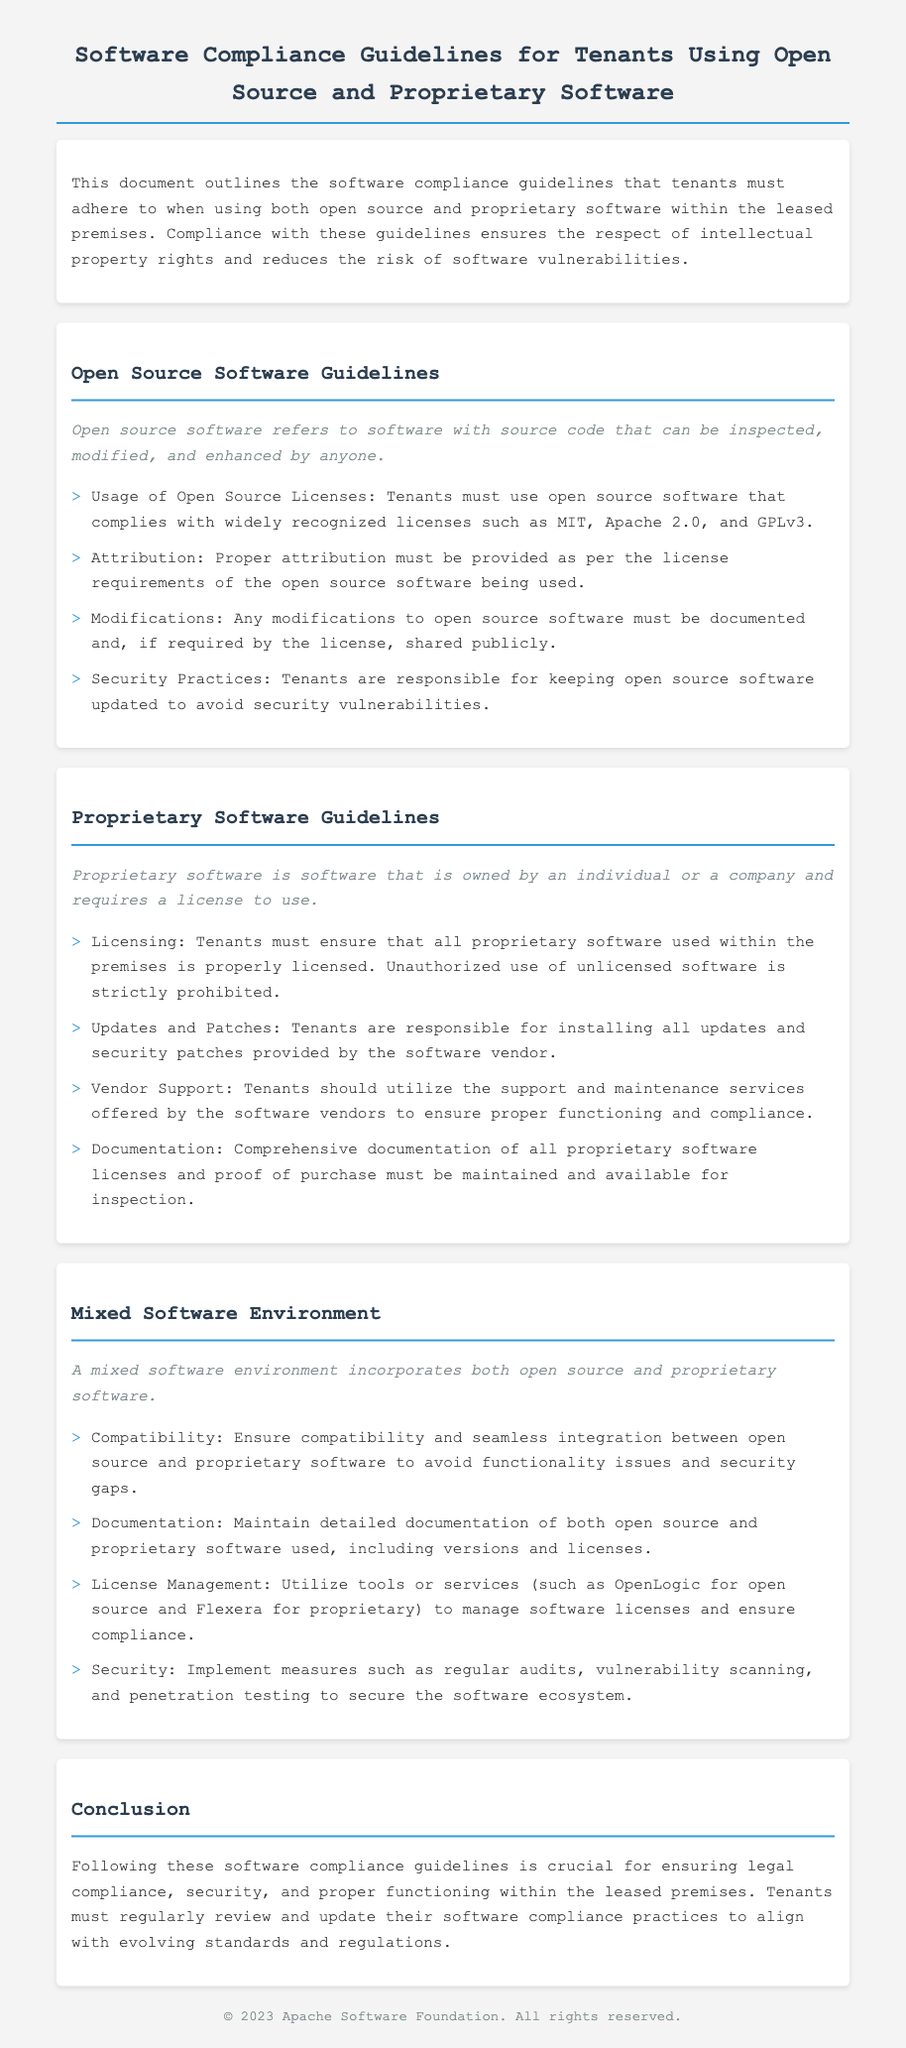What is the title of the document? The title of the document is stated in the header of the rendered page.
Answer: Software Compliance Guidelines for Tenants Using Open Source and Proprietary Software What are the types of software mentioned in the guidelines? The document outlines compliance guidelines for two types of software, which are indicated in the sections.
Answer: Open Source and Proprietary Software What must tenants ensure about proprietary software? This requirement is listed under the Proprietary Software Guidelines section.
Answer: Properly licensed Which licenses must open source software comply with? The document specifies recognized licenses in the Open Source Software Guidelines section.
Answer: MIT, Apache 2.0, and GPLv3 What should be maintained for all proprietary software? This requirement is found in the Proprietary Software Guidelines section, specifically about documentation.
Answer: Comprehensive documentation What is recommended for ensuring compatibility in a mixed software environment? This is mentioned in the Mixed Software Environment guidelines regarding software integration.
Answer: Ensure compatibility and seamless integration What kind of practices must tenants follow for open source software security? This point is highlighted in the Open Source Software Guidelines regarding updates.
Answer: Keeping open source software updated How should modifications to open source software be handled? This guidance is provided in the Open Source Software Guidelines dealing with documentation.
Answer: Documented and, if required, shared publicly 